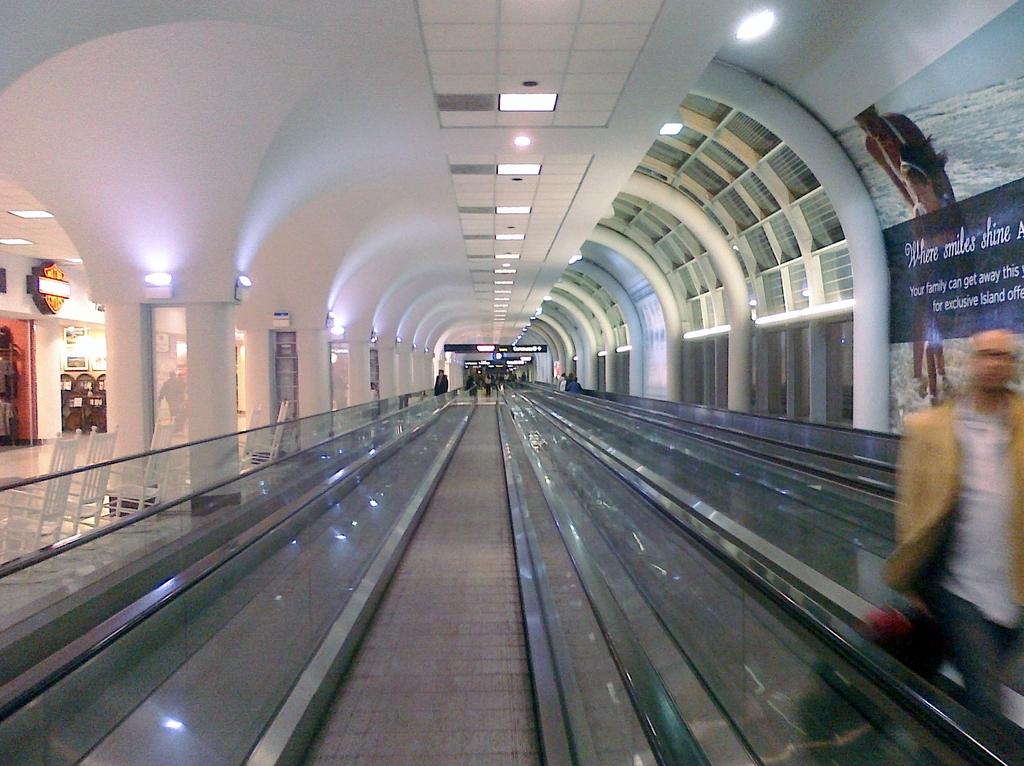What shines at the island shown on the advertisement?
Keep it short and to the point. Smiles. Who can get away, according to the poster on the right?
Ensure brevity in your answer.  Your family. 